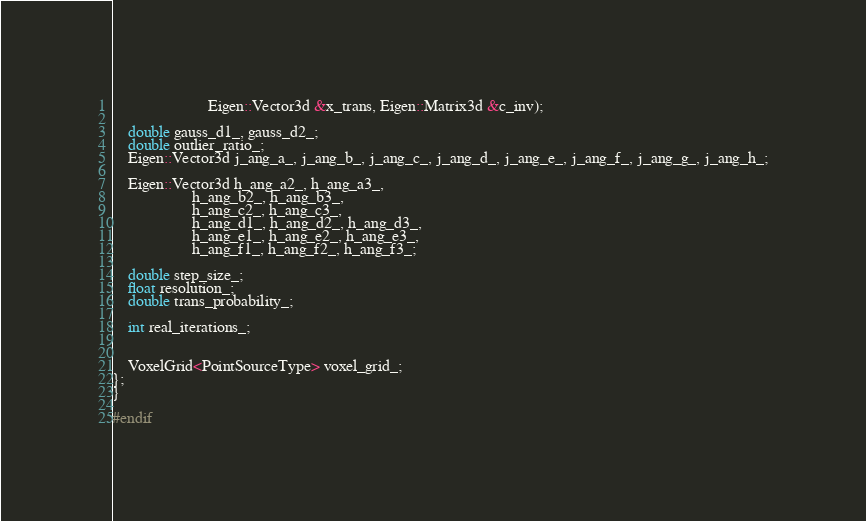Convert code to text. <code><loc_0><loc_0><loc_500><loc_500><_C_>						Eigen::Vector3d &x_trans, Eigen::Matrix3d &c_inv);

	double gauss_d1_, gauss_d2_;
	double outlier_ratio_;
	Eigen::Vector3d j_ang_a_, j_ang_b_, j_ang_c_, j_ang_d_, j_ang_e_, j_ang_f_, j_ang_g_, j_ang_h_;

	Eigen::Vector3d h_ang_a2_, h_ang_a3_,
					h_ang_b2_, h_ang_b3_,
					h_ang_c2_, h_ang_c3_,
					h_ang_d1_, h_ang_d2_, h_ang_d3_,
					h_ang_e1_, h_ang_e2_, h_ang_e3_,
					h_ang_f1_, h_ang_f2_, h_ang_f3_;

	double step_size_;
	float resolution_;
	double trans_probability_;

	int real_iterations_;


	VoxelGrid<PointSourceType> voxel_grid_;
};
}

#endif
</code> 